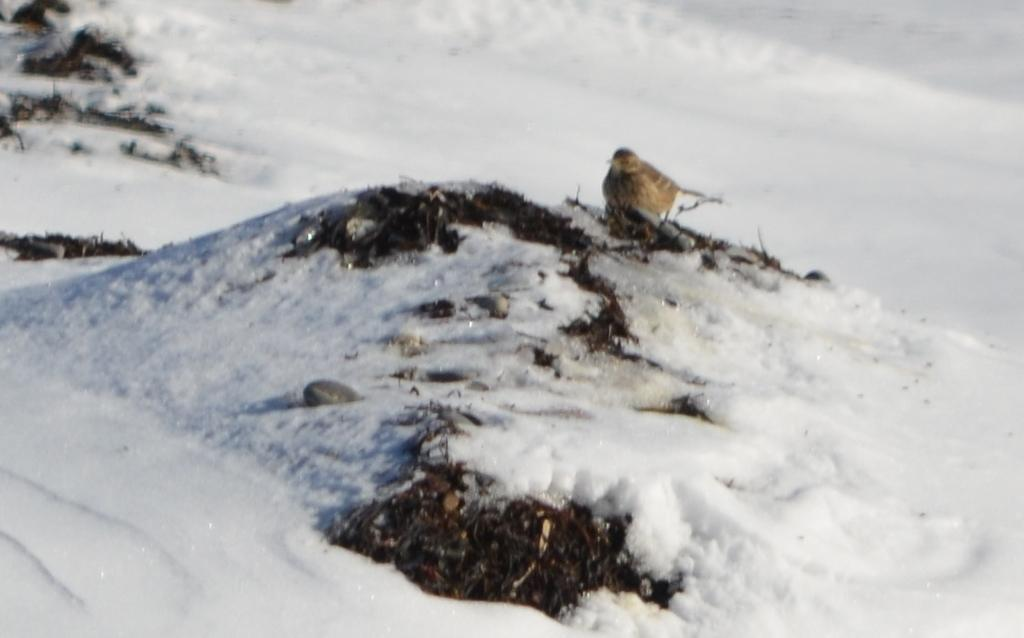What is the condition of the ground in the image? There is snow on the ground in the image. What can be seen in the center of the image? There is a bird in the center of the image. What color are the objects on the left side of the image? The objects on the left side of the image are black in color. How many eggs are visible in the image? There are no eggs present in the image. What type of spiders can be seen crawling on the bird in the image? There are no spiders visible in the image; it features a bird in the center of the image. 